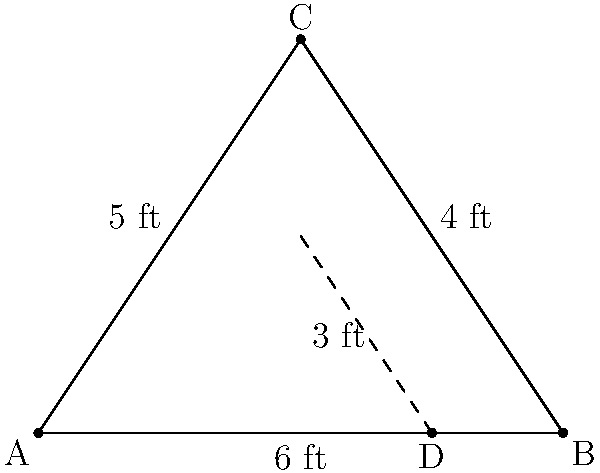In the poster for a new Marathi comedy film, three characters are arranged in a triangle. The tallest character is 6 feet, the shortest is 4 feet, and the middle one is 5 feet tall. If a fourth character, who is 3 feet tall, stands in front of the poster, how far along the base of the triangle (as a fraction of the total base length) should they stand to appear the same height as the other characters in the poster? Let's approach this step-by-step:

1) First, we need to recognize that this is a problem of similar triangles. The triangle formed by the three characters in the poster and the triangle formed by including the fourth character should be similar.

2) Let's label the corners of the triangle as A, B (base corners), and C (top corner). The fourth character's position will be D.

3) We know that:
   AB = 6 feet (base of the triangle)
   AC = 5 feet (height of the middle character)
   BC = 4 feet (height of the shortest character in the poster)
   AD = 3 feet (height of the fourth character)

4) For the triangles to be similar, we need:
   $\frac{AD}{AC} = \frac{AD}{AB}$

5) We can set up the equation:
   $\frac{3}{5} = \frac{x}{6}$, where x is the distance from A to D.

6) Cross multiply:
   $3 * 6 = 5x$
   $18 = 5x$

7) Solve for x:
   $x = \frac{18}{5} = 3.6$ feet

8) To express this as a fraction of the total base length:
   $\frac{3.6}{6} = \frac{3}{5} = 0.6$

Therefore, the fourth character should stand 3/5 or 0.6 of the way along the base of the triangle.
Answer: $\frac{3}{5}$ or 0.6 